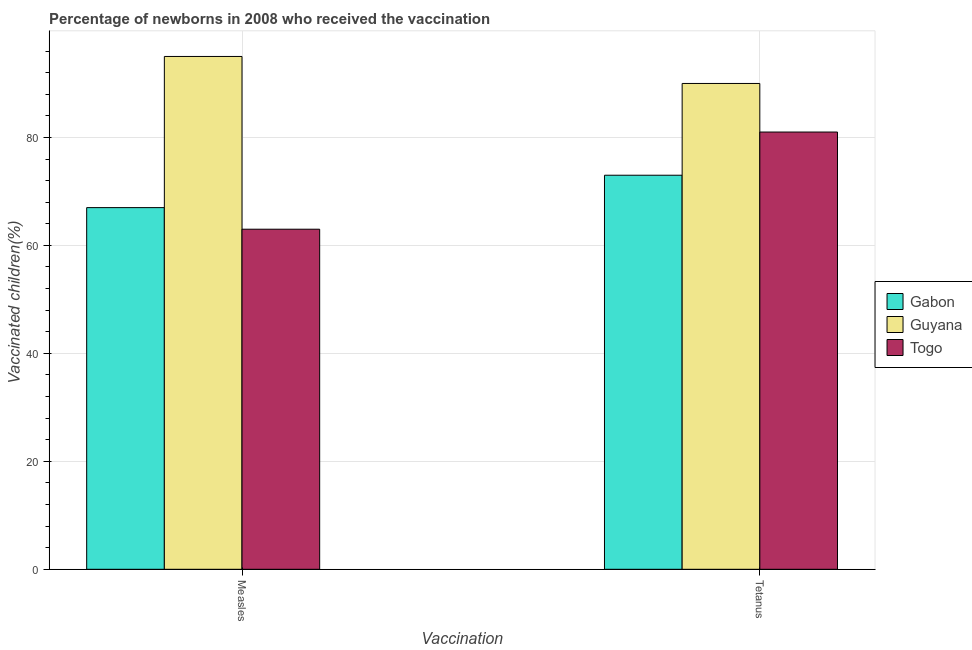How many different coloured bars are there?
Make the answer very short. 3. How many groups of bars are there?
Make the answer very short. 2. How many bars are there on the 2nd tick from the left?
Provide a short and direct response. 3. What is the label of the 2nd group of bars from the left?
Offer a terse response. Tetanus. What is the percentage of newborns who received vaccination for measles in Togo?
Keep it short and to the point. 63. Across all countries, what is the maximum percentage of newborns who received vaccination for measles?
Give a very brief answer. 95. Across all countries, what is the minimum percentage of newborns who received vaccination for tetanus?
Offer a terse response. 73. In which country was the percentage of newborns who received vaccination for tetanus maximum?
Keep it short and to the point. Guyana. In which country was the percentage of newborns who received vaccination for tetanus minimum?
Your answer should be very brief. Gabon. What is the total percentage of newborns who received vaccination for measles in the graph?
Keep it short and to the point. 225. What is the difference between the percentage of newborns who received vaccination for measles in Gabon and that in Guyana?
Ensure brevity in your answer.  -28. What is the difference between the percentage of newborns who received vaccination for measles in Guyana and the percentage of newborns who received vaccination for tetanus in Togo?
Ensure brevity in your answer.  14. What is the difference between the percentage of newborns who received vaccination for measles and percentage of newborns who received vaccination for tetanus in Togo?
Offer a very short reply. -18. What is the ratio of the percentage of newborns who received vaccination for measles in Guyana to that in Gabon?
Provide a short and direct response. 1.42. What does the 3rd bar from the left in Tetanus represents?
Make the answer very short. Togo. What does the 1st bar from the right in Measles represents?
Offer a very short reply. Togo. How many bars are there?
Provide a succinct answer. 6. Are all the bars in the graph horizontal?
Your answer should be compact. No. How many countries are there in the graph?
Make the answer very short. 3. Does the graph contain grids?
Make the answer very short. Yes. Where does the legend appear in the graph?
Your answer should be very brief. Center right. How many legend labels are there?
Offer a very short reply. 3. What is the title of the graph?
Your answer should be compact. Percentage of newborns in 2008 who received the vaccination. What is the label or title of the X-axis?
Provide a succinct answer. Vaccination. What is the label or title of the Y-axis?
Provide a succinct answer. Vaccinated children(%)
. What is the Vaccinated children(%)
 of Guyana in Measles?
Your response must be concise. 95. What is the Vaccinated children(%)
 in Togo in Measles?
Ensure brevity in your answer.  63. What is the Vaccinated children(%)
 in Gabon in Tetanus?
Your answer should be very brief. 73. What is the Vaccinated children(%)
 in Guyana in Tetanus?
Provide a succinct answer. 90. What is the Vaccinated children(%)
 in Togo in Tetanus?
Ensure brevity in your answer.  81. Across all Vaccination, what is the maximum Vaccinated children(%)
 in Gabon?
Ensure brevity in your answer.  73. Across all Vaccination, what is the maximum Vaccinated children(%)
 of Guyana?
Give a very brief answer. 95. Across all Vaccination, what is the minimum Vaccinated children(%)
 of Togo?
Ensure brevity in your answer.  63. What is the total Vaccinated children(%)
 of Gabon in the graph?
Provide a succinct answer. 140. What is the total Vaccinated children(%)
 in Guyana in the graph?
Make the answer very short. 185. What is the total Vaccinated children(%)
 in Togo in the graph?
Provide a short and direct response. 144. What is the difference between the Vaccinated children(%)
 of Togo in Measles and that in Tetanus?
Your answer should be compact. -18. What is the difference between the Vaccinated children(%)
 of Gabon in Measles and the Vaccinated children(%)
 of Togo in Tetanus?
Make the answer very short. -14. What is the average Vaccinated children(%)
 in Gabon per Vaccination?
Offer a terse response. 70. What is the average Vaccinated children(%)
 in Guyana per Vaccination?
Offer a very short reply. 92.5. What is the difference between the Vaccinated children(%)
 in Guyana and Vaccinated children(%)
 in Togo in Measles?
Offer a very short reply. 32. What is the difference between the Vaccinated children(%)
 in Gabon and Vaccinated children(%)
 in Guyana in Tetanus?
Ensure brevity in your answer.  -17. What is the difference between the Vaccinated children(%)
 in Gabon and Vaccinated children(%)
 in Togo in Tetanus?
Provide a succinct answer. -8. What is the ratio of the Vaccinated children(%)
 in Gabon in Measles to that in Tetanus?
Keep it short and to the point. 0.92. What is the ratio of the Vaccinated children(%)
 in Guyana in Measles to that in Tetanus?
Your response must be concise. 1.06. What is the difference between the highest and the second highest Vaccinated children(%)
 of Togo?
Offer a terse response. 18. What is the difference between the highest and the lowest Vaccinated children(%)
 of Gabon?
Make the answer very short. 6. 